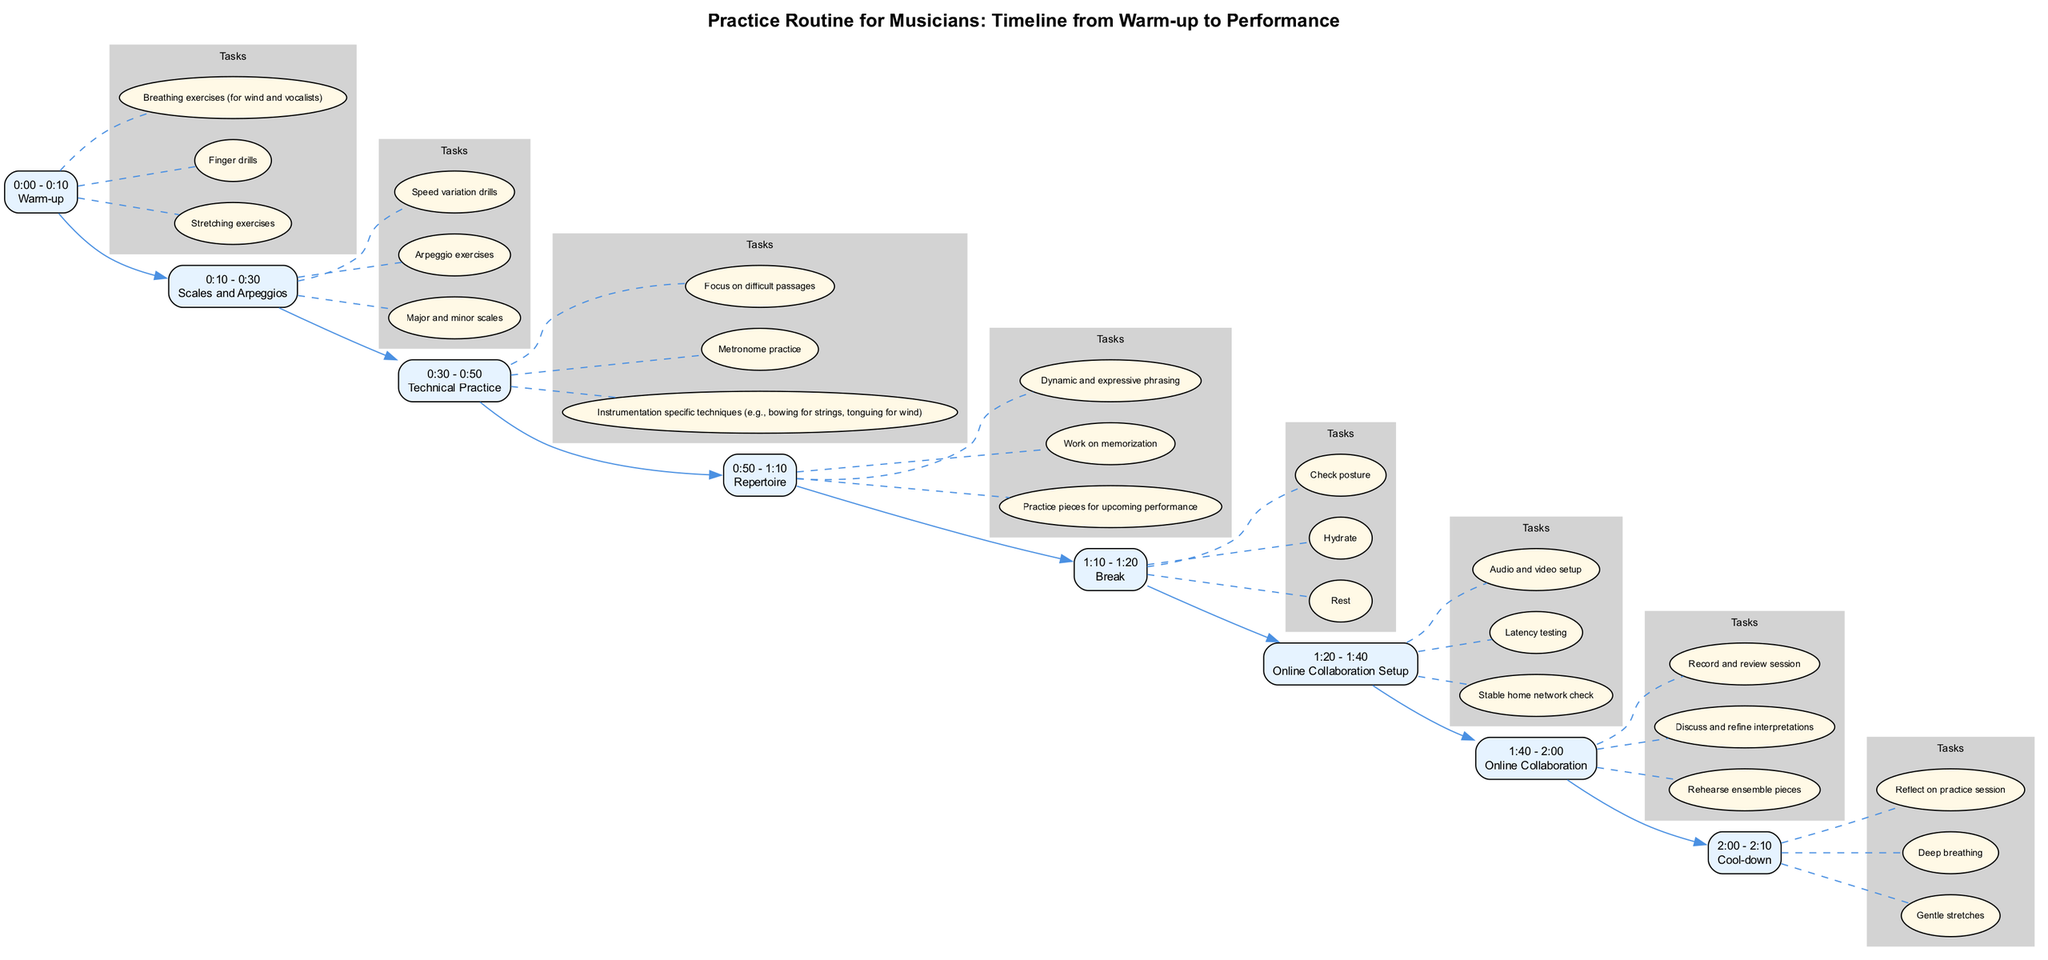What is the first activity in the practice routine? The practice routine starts with the 'Warm-up' activity, which is the first node in the diagram.
Answer: Warm-up How long is the 'Scales and Arpeggios' activity? The 'Scales and Arpeggios' activity is scheduled for 20 minutes, from 0:10 to 0:30.
Answer: 20 minutes What are the tasks involved in the 'Repertoire' activity? The tasks for the 'Repertoire' activity include practicing pieces for an upcoming performance, working on memorization, and focusing on dynamic and expressive phrasing.
Answer: Practice pieces for upcoming performance, work on memorization, dynamic and expressive phrasing Which activity follows the 'Break'? After the 'Break' activity, which lasts from 1:10 to 1:20, the next activity is 'Online Collaboration Setup'.
Answer: Online Collaboration Setup How many total activities are there in the diagram? The diagram shows a total of 8 activities, ranging from Warm-up to Cool-down.
Answer: 8 activities What is the purpose of the 'Online Collaboration Setup'? The 'Online Collaboration Setup' involves checking the stable home network, performing latency tests, and setting up audio and video for online collaboration.
Answer: Stable home network check, latency testing, audio and video setup Which activity has a break specified before it? The 'Online Collaboration' activity has a break specified before it, allowing for rest and preparation before this collaborative task.
Answer: Online Collaboration What time is allocated for the 'Cool-down' activity? The 'Cool-down' activity is allocated 10 minutes, from 2:00 to 2:10, allowing musicians to unwind after practice.
Answer: 10 minutes 